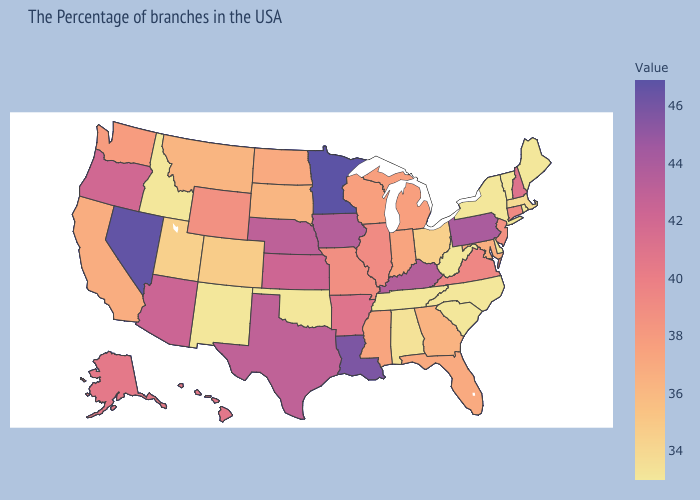Among the states that border Florida , does Alabama have the highest value?
Keep it brief. No. Which states have the highest value in the USA?
Keep it brief. Minnesota. Among the states that border New Jersey , does Pennsylvania have the highest value?
Quick response, please. Yes. Does the map have missing data?
Be succinct. No. Does the map have missing data?
Answer briefly. No. 